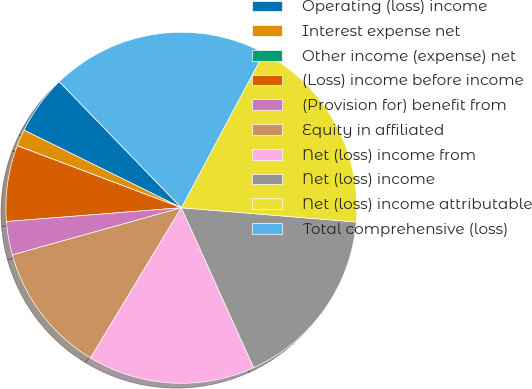Convert chart. <chart><loc_0><loc_0><loc_500><loc_500><pie_chart><fcel>Operating (loss) income<fcel>Interest expense net<fcel>Other income (expense) net<fcel>(Loss) income before income<fcel>(Provision for) benefit from<fcel>Equity in affiliated<fcel>Net (loss) income from<fcel>Net (loss) income<fcel>Net (loss) income attributable<fcel>Total comprehensive (loss)<nl><fcel>5.46%<fcel>1.54%<fcel>0.0%<fcel>7.0%<fcel>3.08%<fcel>12.01%<fcel>15.41%<fcel>16.95%<fcel>18.49%<fcel>20.04%<nl></chart> 